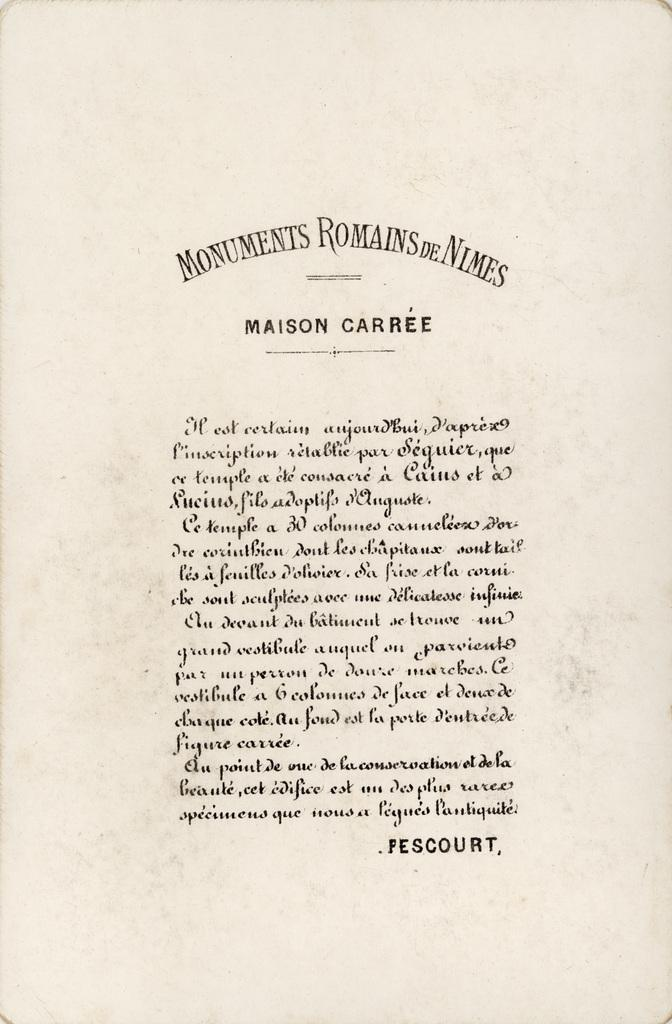<image>
Present a compact description of the photo's key features. Letter that was written and has the text: Monuments Romains De Nimes. 